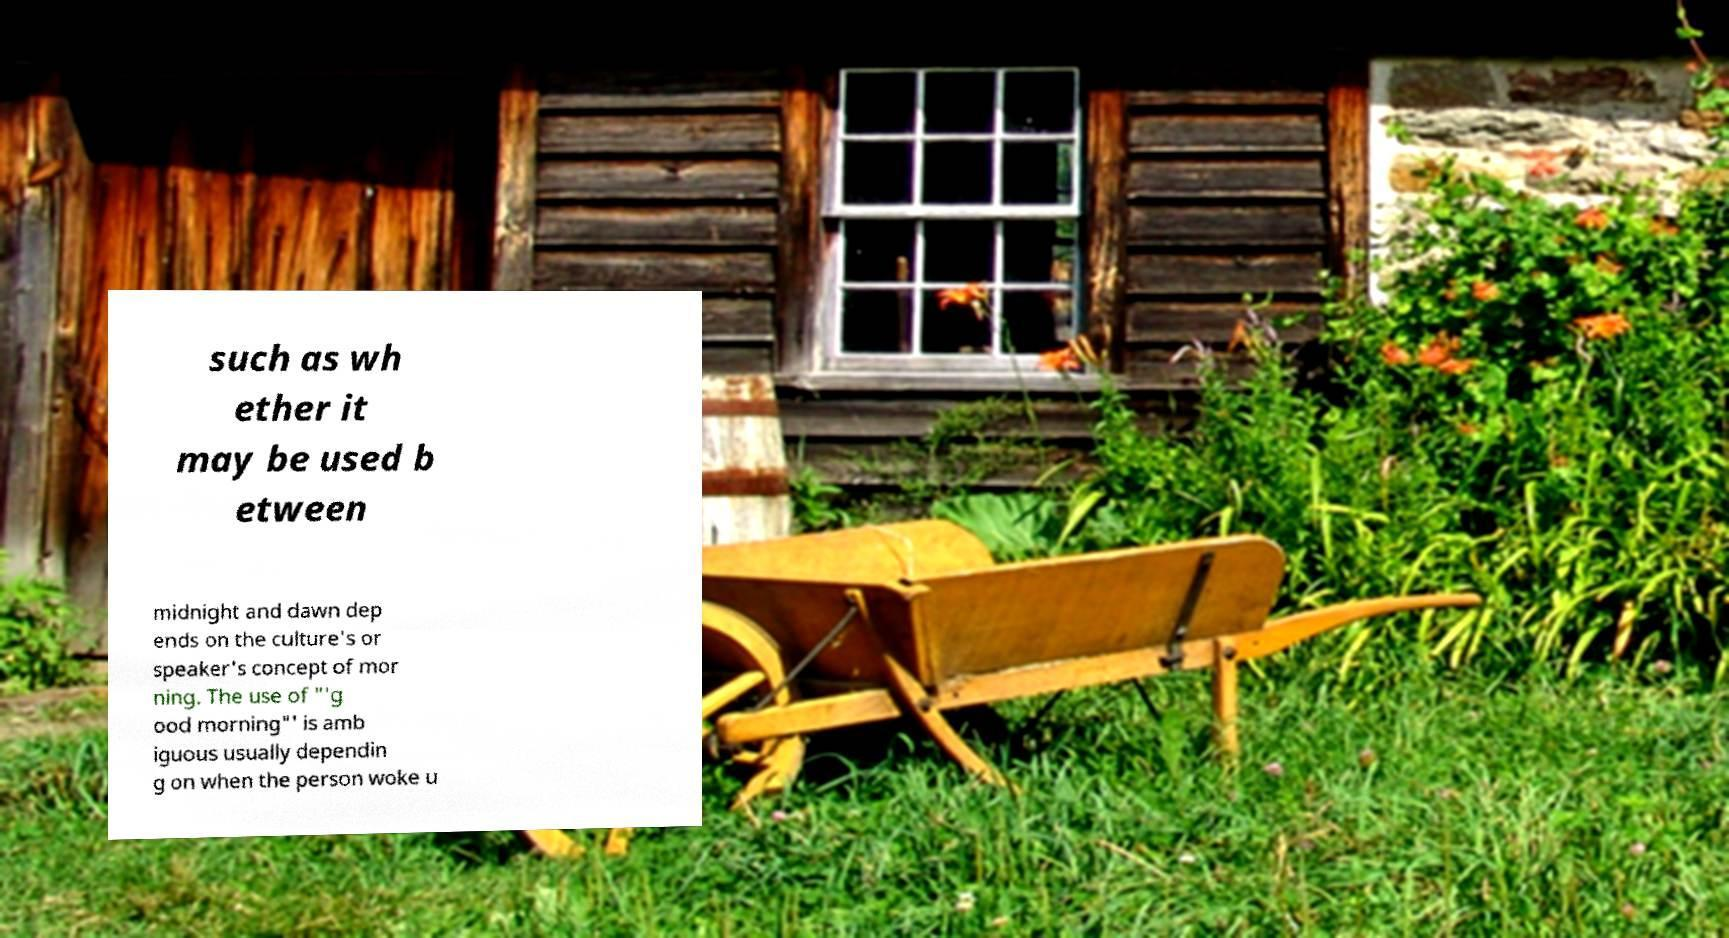There's text embedded in this image that I need extracted. Can you transcribe it verbatim? such as wh ether it may be used b etween midnight and dawn dep ends on the culture's or speaker's concept of mor ning. The use of "'g ood morning"' is amb iguous usually dependin g on when the person woke u 